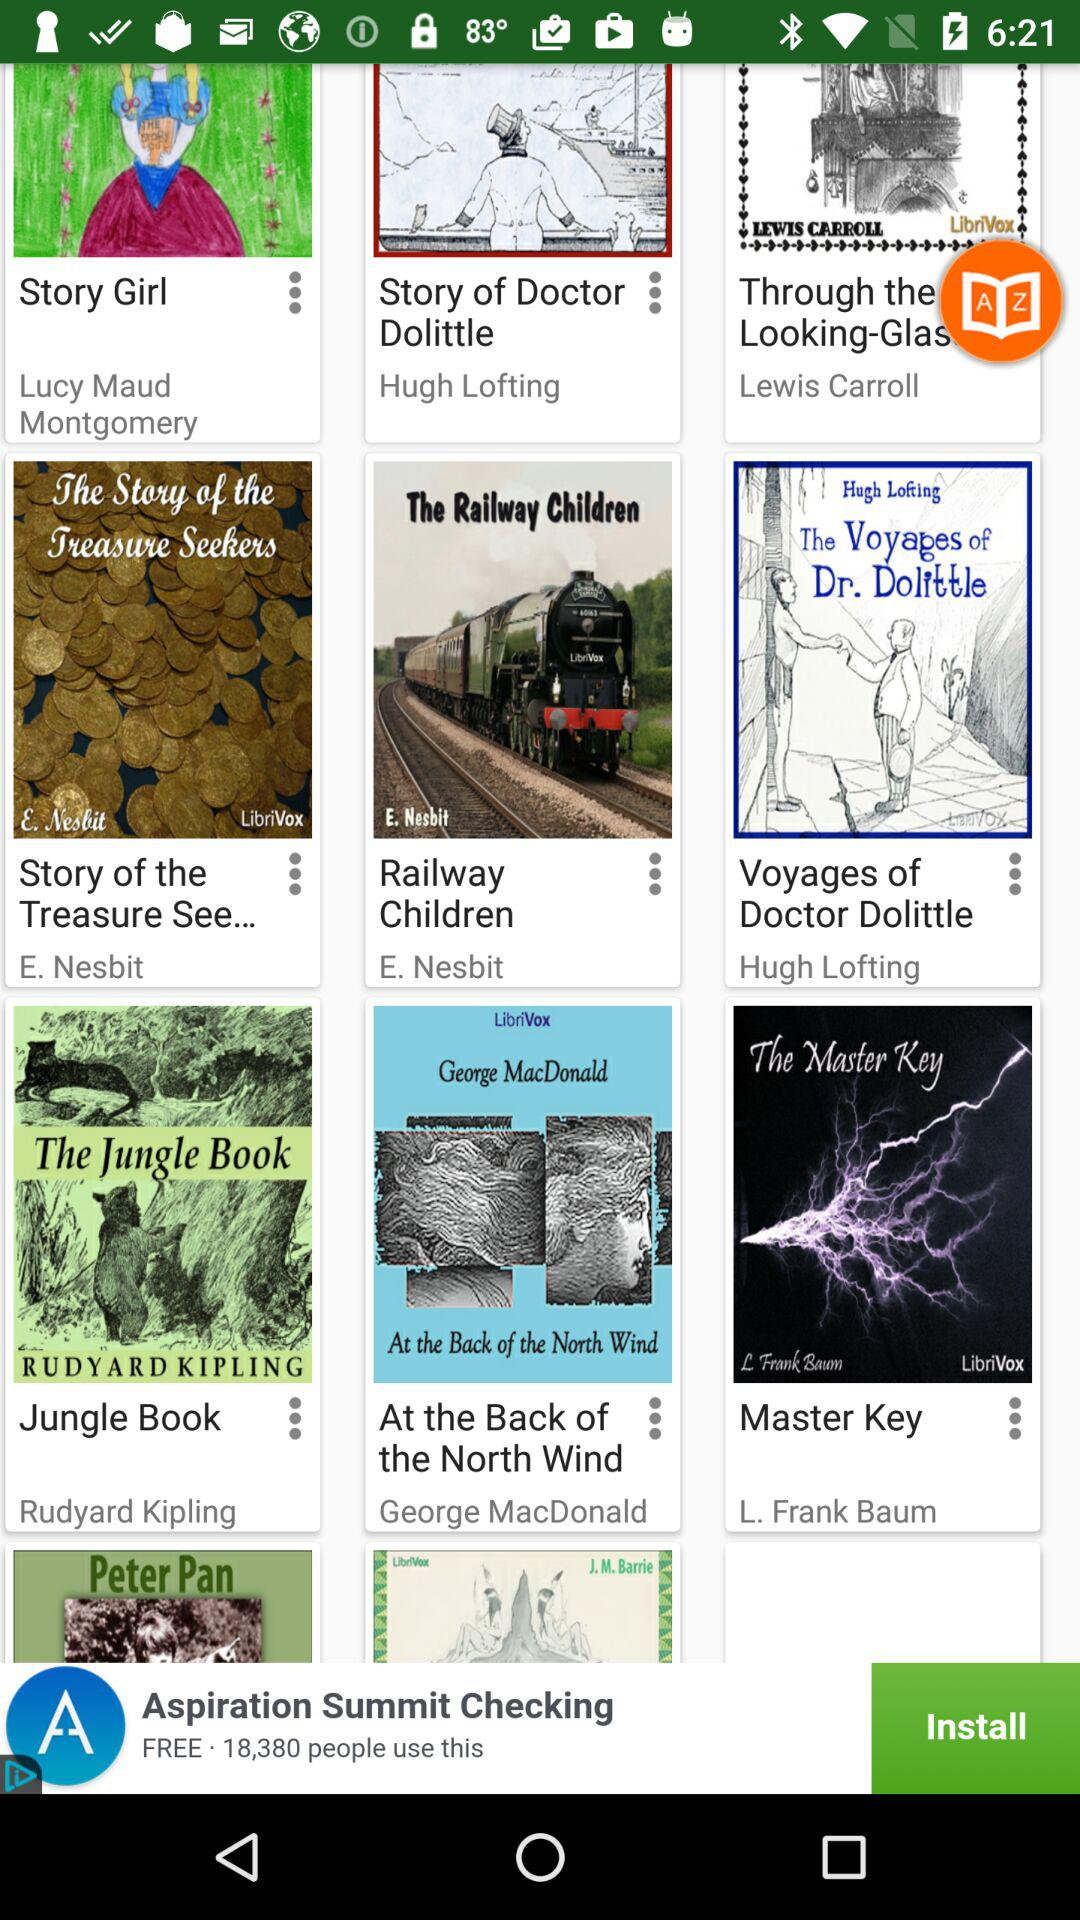Which book is written by the author Rudyard Kipling? The book that is written by the author Rudyard Kipling is "Jungle Book". 